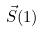<formula> <loc_0><loc_0><loc_500><loc_500>\vec { S } ( 1 )</formula> 